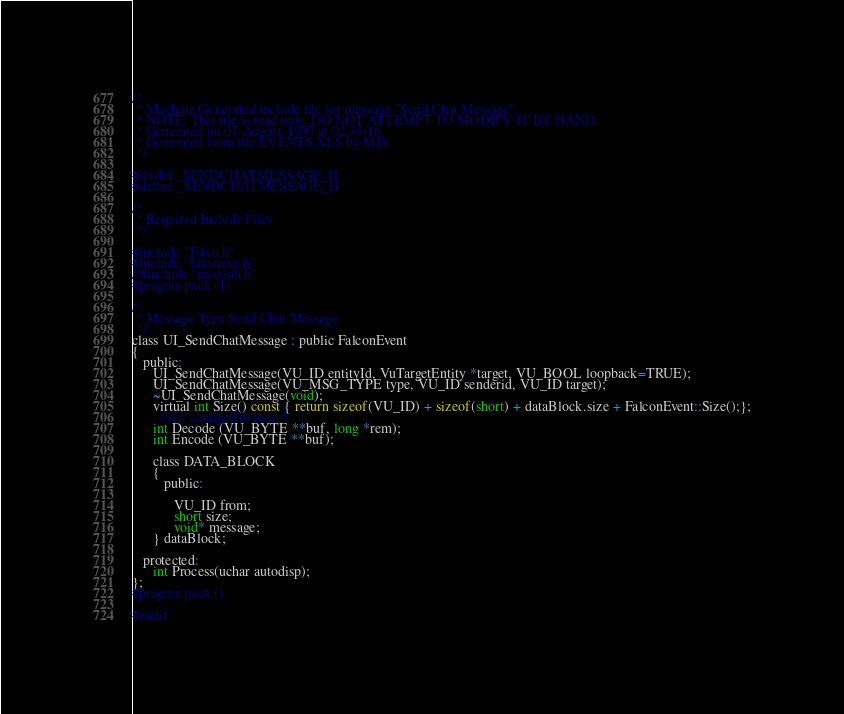Convert code to text. <code><loc_0><loc_0><loc_500><loc_500><_C_>/*
 * Machine Generated include file for message "Send Chat Message".
 * NOTE: This file is read only. DO NOT ATTEMPT TO MODIFY IT BY HAND.
 * Generated on 07-August-1997 at 02:38:16
 * Generated from file EVENTS.XLS by MIS
 */

#ifndef _SENDCHATMESSAGE_H
#define _SENDCHATMESSAGE_H

/*
 * Required Include Files
 */

#include "F4vu.h"
#include "falcmesg.h"
//#include "mission.h"
#pragma pack (1)

/*
 * Message Type Send Chat Message
 */
class UI_SendChatMessage : public FalconEvent
{
   public:
      UI_SendChatMessage(VU_ID entityId, VuTargetEntity *target, VU_BOOL loopback=TRUE);
      UI_SendChatMessage(VU_MSG_TYPE type, VU_ID senderid, VU_ID target);
      ~UI_SendChatMessage(void);
      virtual int Size() const { return sizeof(VU_ID) + sizeof(short) + dataBlock.size + FalconEvent::Size();};
		//sfr: changed to long *
	  int Decode (VU_BYTE **buf, long *rem);
      int Encode (VU_BYTE **buf);

      class DATA_BLOCK
      {
         public:

            VU_ID from;
            short size;
            void* message;
      } dataBlock;

   protected:
      int Process(uchar autodisp);
};
#pragma pack ()

#endif
</code> 